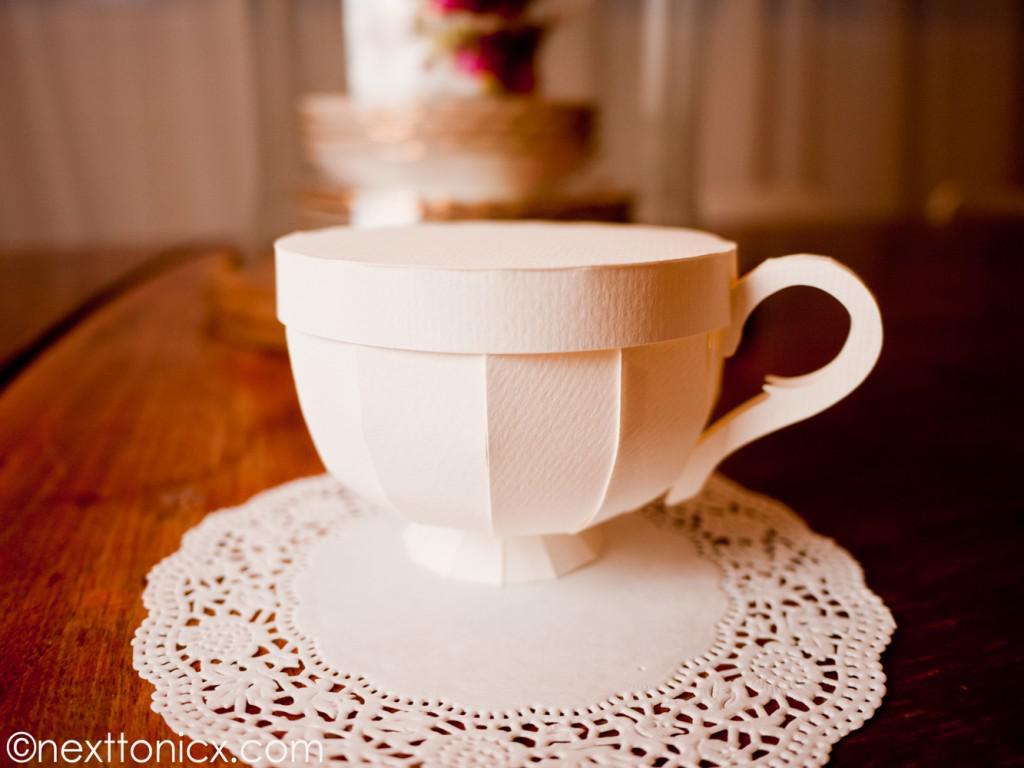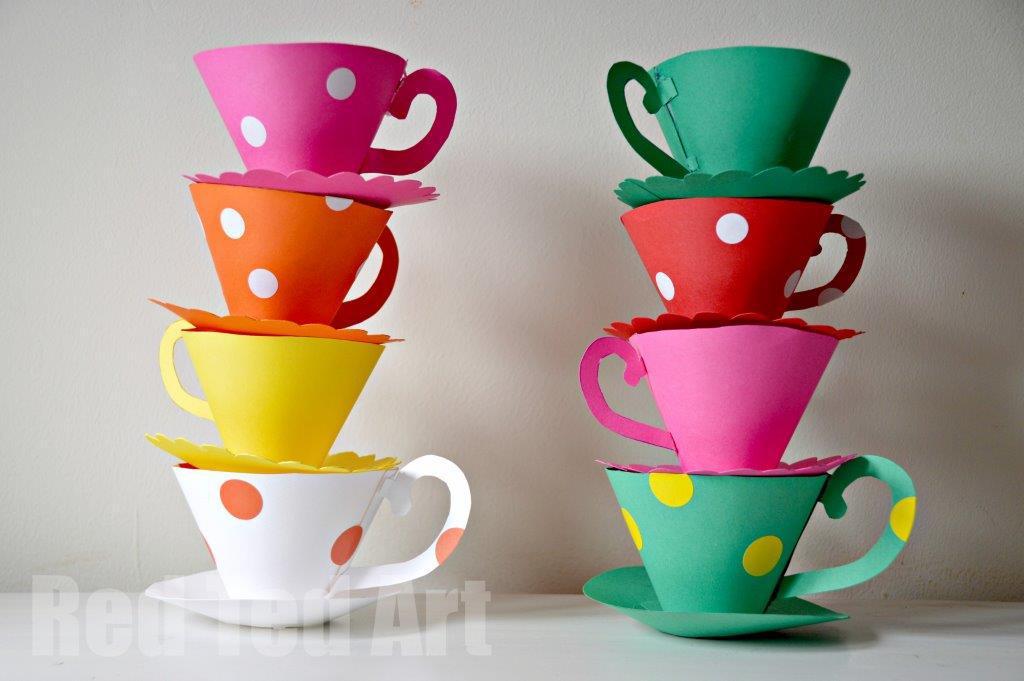The first image is the image on the left, the second image is the image on the right. For the images displayed, is the sentence "An image shows at least two stacks of at least three cups on matching saucers, featuring different solid colors, polka dots, and scalloped edges." factually correct? Answer yes or no. Yes. The first image is the image on the left, the second image is the image on the right. Assess this claim about the two images: "There is a solid white cup.". Correct or not? Answer yes or no. Yes. 